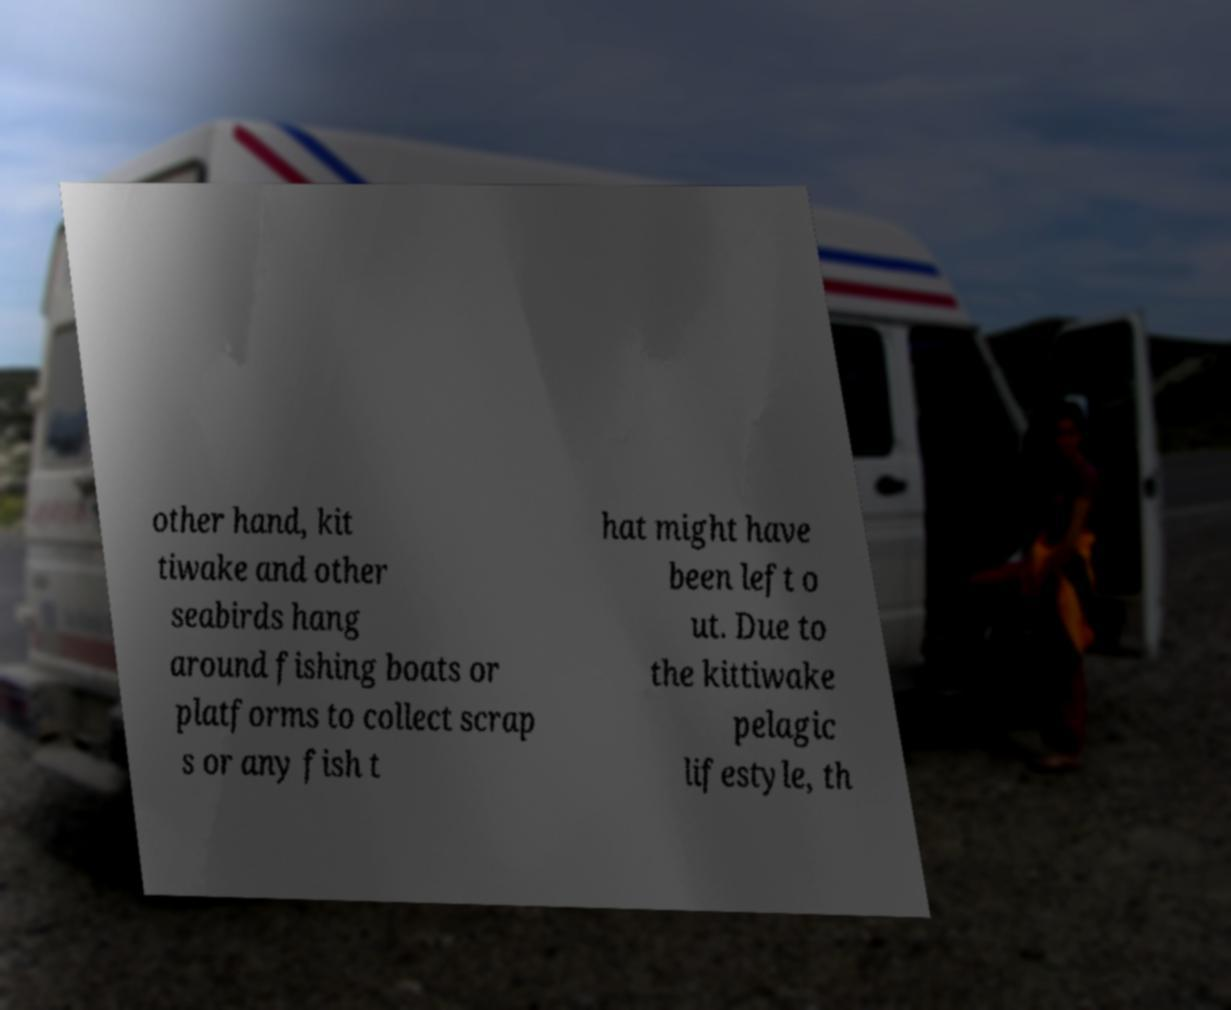Please identify and transcribe the text found in this image. other hand, kit tiwake and other seabirds hang around fishing boats or platforms to collect scrap s or any fish t hat might have been left o ut. Due to the kittiwake pelagic lifestyle, th 